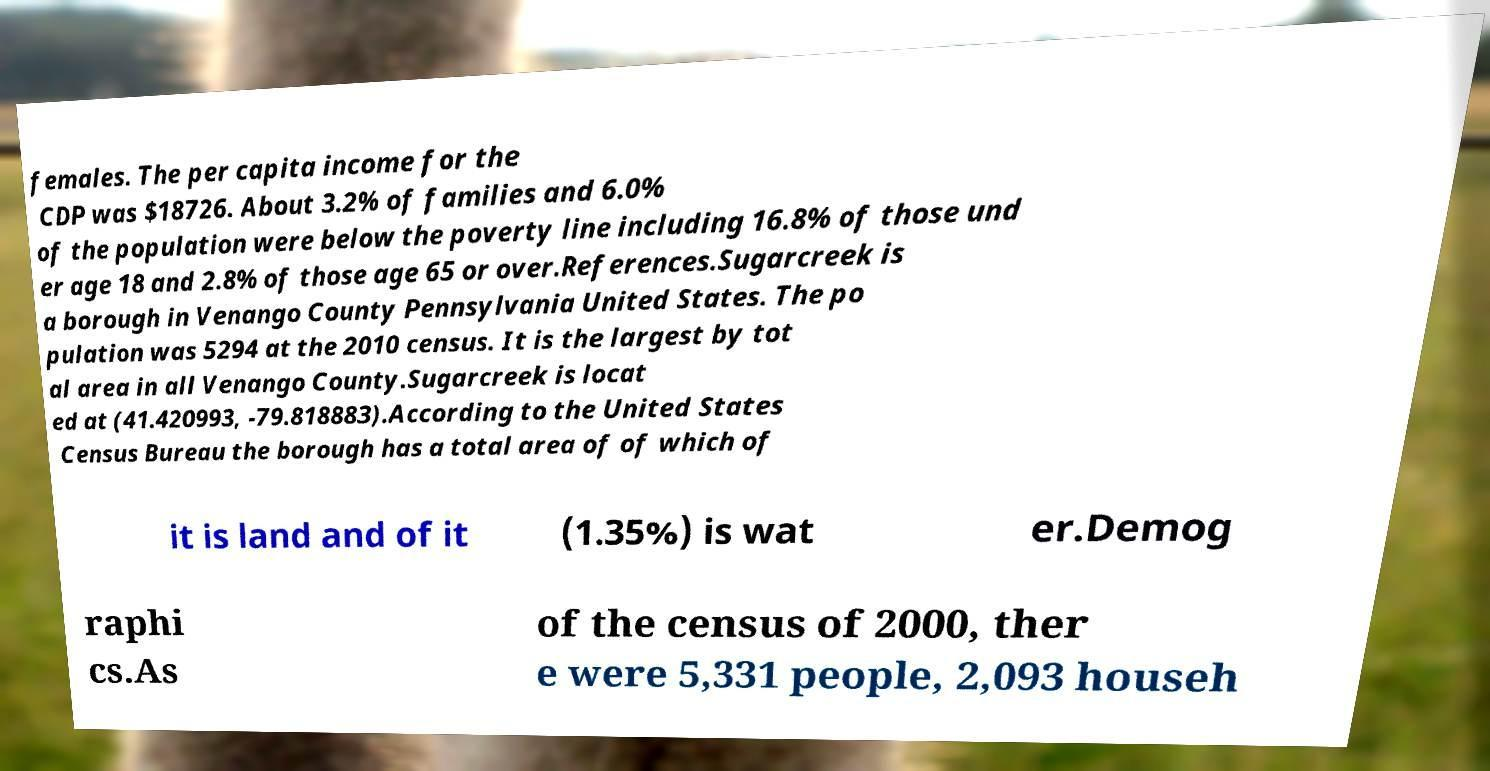Could you extract and type out the text from this image? females. The per capita income for the CDP was $18726. About 3.2% of families and 6.0% of the population were below the poverty line including 16.8% of those und er age 18 and 2.8% of those age 65 or over.References.Sugarcreek is a borough in Venango County Pennsylvania United States. The po pulation was 5294 at the 2010 census. It is the largest by tot al area in all Venango County.Sugarcreek is locat ed at (41.420993, -79.818883).According to the United States Census Bureau the borough has a total area of of which of it is land and of it (1.35%) is wat er.Demog raphi cs.As of the census of 2000, ther e were 5,331 people, 2,093 househ 